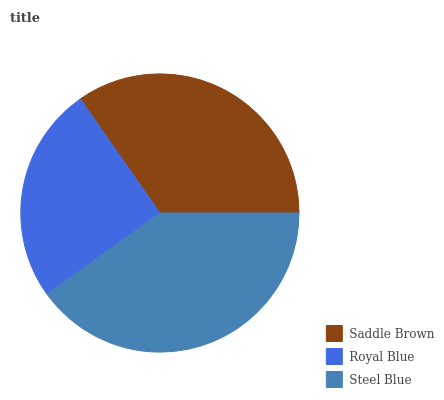Is Royal Blue the minimum?
Answer yes or no. Yes. Is Steel Blue the maximum?
Answer yes or no. Yes. Is Steel Blue the minimum?
Answer yes or no. No. Is Royal Blue the maximum?
Answer yes or no. No. Is Steel Blue greater than Royal Blue?
Answer yes or no. Yes. Is Royal Blue less than Steel Blue?
Answer yes or no. Yes. Is Royal Blue greater than Steel Blue?
Answer yes or no. No. Is Steel Blue less than Royal Blue?
Answer yes or no. No. Is Saddle Brown the high median?
Answer yes or no. Yes. Is Saddle Brown the low median?
Answer yes or no. Yes. Is Royal Blue the high median?
Answer yes or no. No. Is Royal Blue the low median?
Answer yes or no. No. 